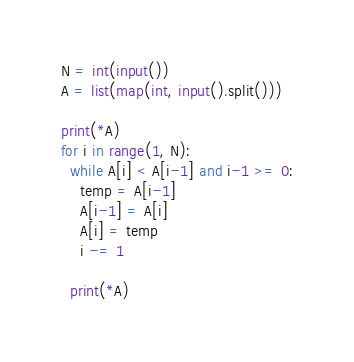Convert code to text. <code><loc_0><loc_0><loc_500><loc_500><_Python_>N = int(input())
A = list(map(int, input().split()))

print(*A)
for i in range(1, N):
  while A[i] < A[i-1] and i-1 >= 0:
    temp = A[i-1]
    A[i-1] = A[i] 
    A[i] = temp
    i -= 1
 
  print(*A)
</code> 